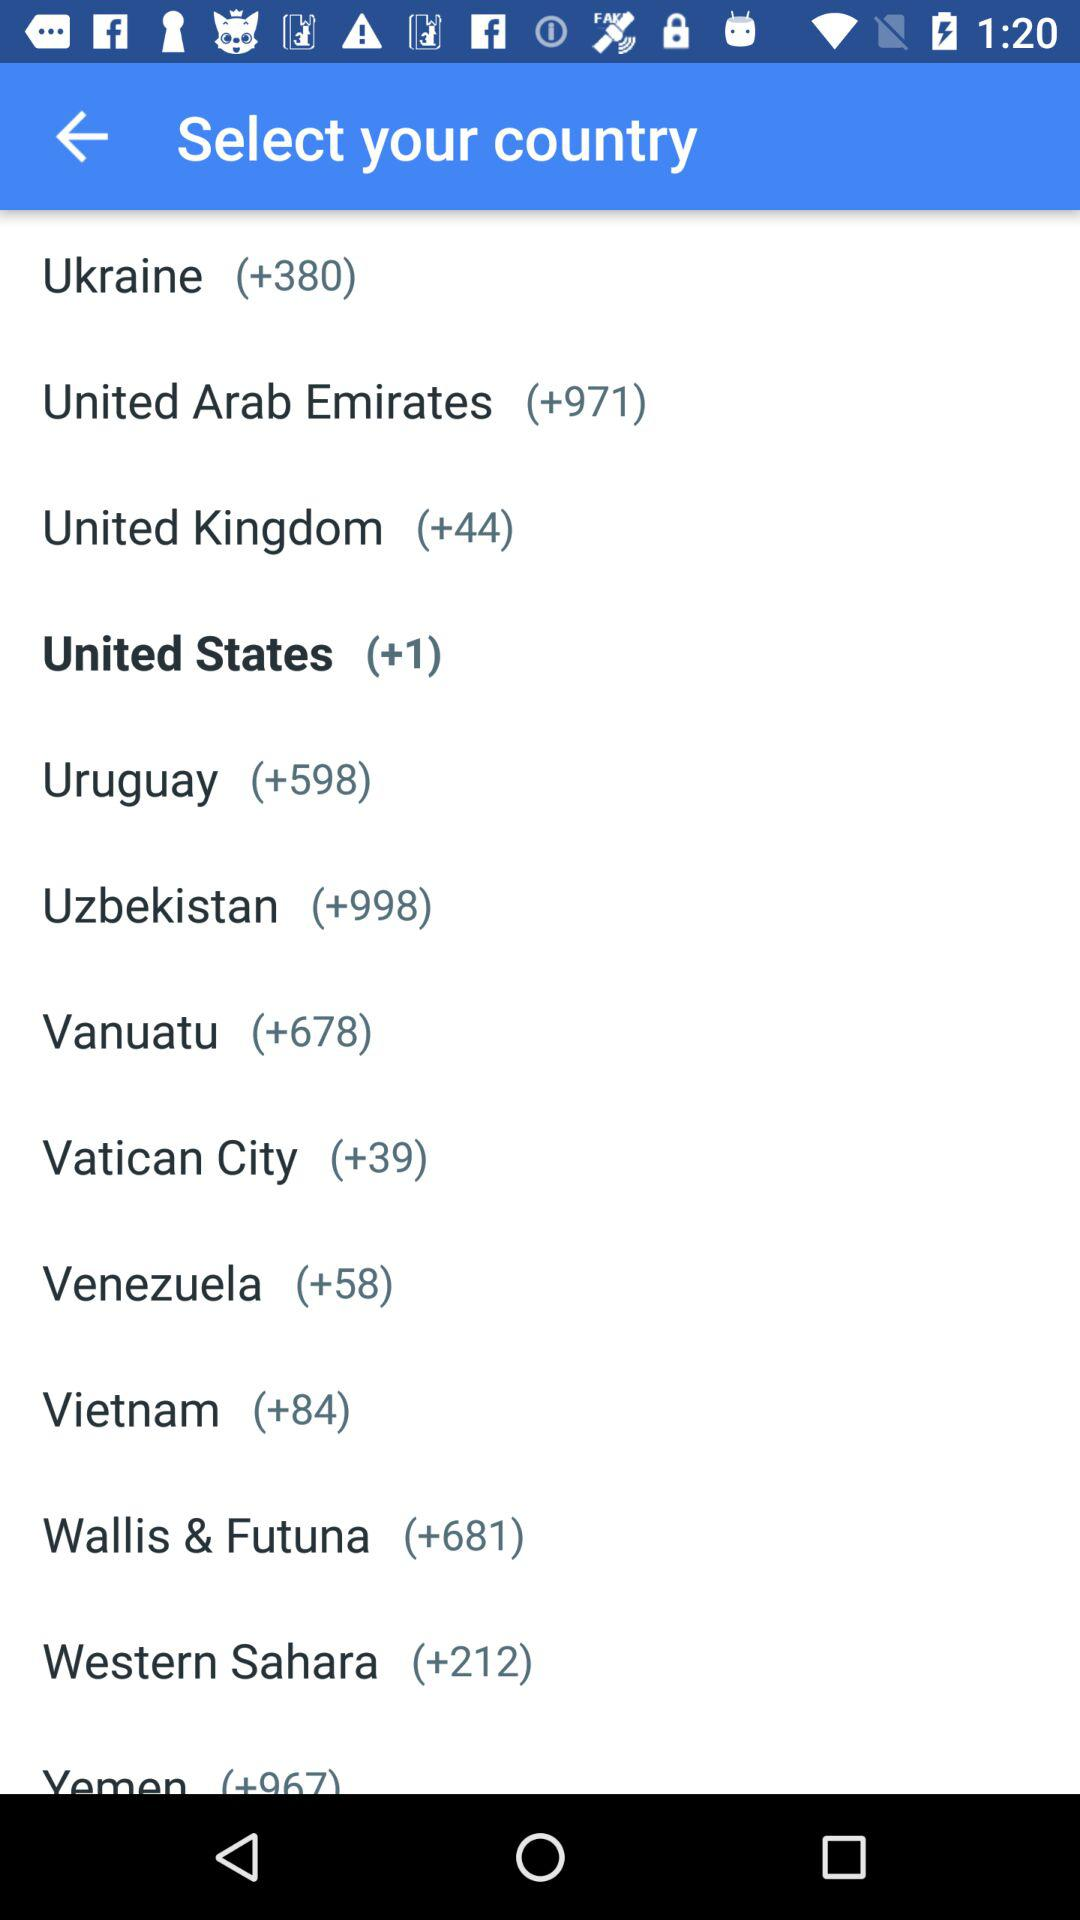What is the Vietnam dialing code? The dialing code is +84. 